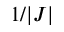<formula> <loc_0><loc_0><loc_500><loc_500>1 / | J |</formula> 